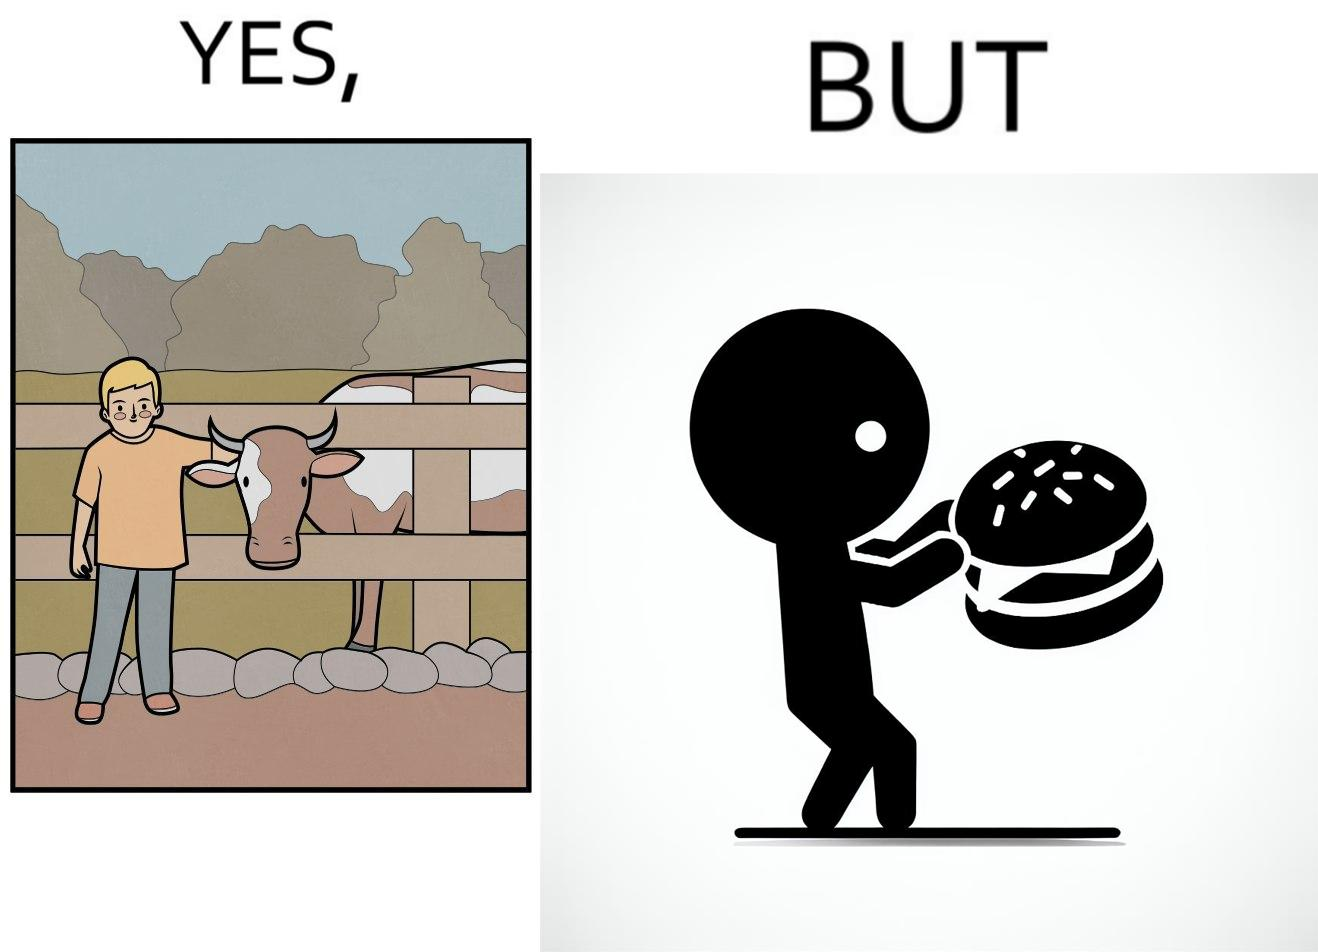What is shown in this image? The irony is that the boy is petting the cow to show that he cares about the animal, but then he also eats hamburgers made from the same cows 